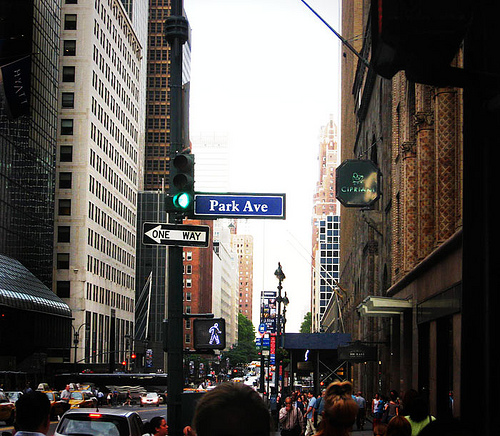<image>What does the red sign say? There is no red sign in the image. However, it could potentially say 'restaurant', 'park ave', or 'stop'. What does the red sign say? The red sign does not say anything. 